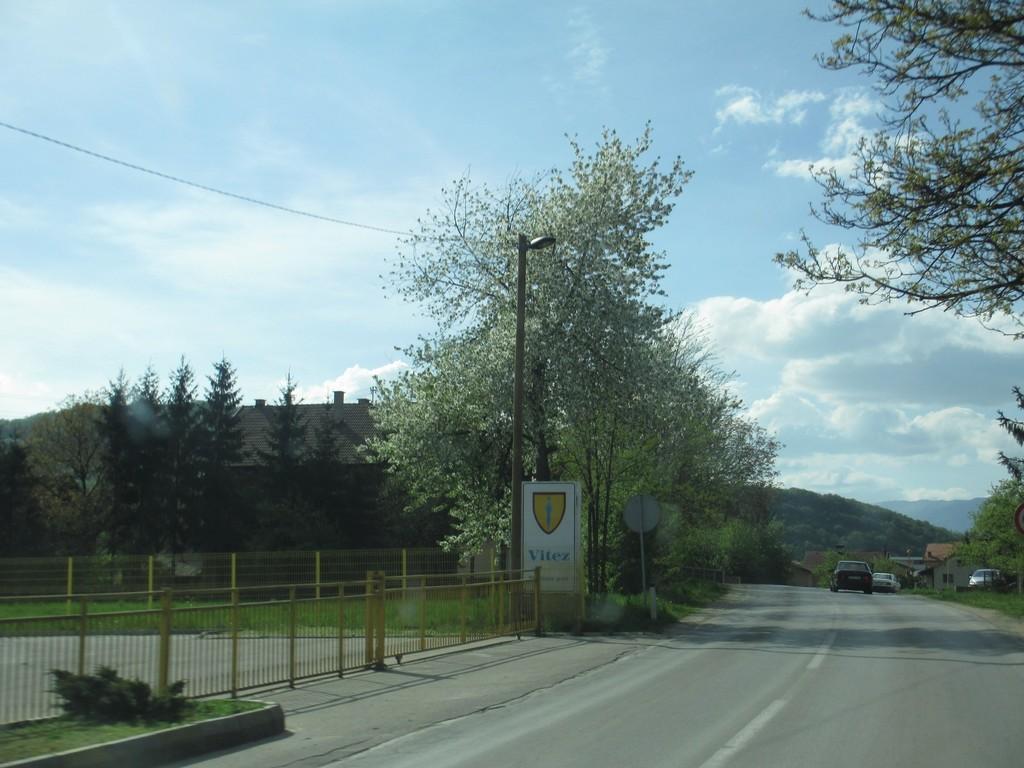Can you describe this image briefly? On the background of the picture we can see sky with clouds. There is a hill. This is a tree. This is a board starting vitex. we can see the fence in the middle of the road. This is a road. There are three cars over here. We can see a house. This is a wall. This is a grass. We can see light with a pole. 